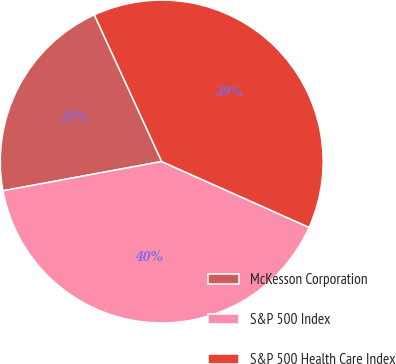Convert chart to OTSL. <chart><loc_0><loc_0><loc_500><loc_500><pie_chart><fcel>McKesson Corporation<fcel>S&P 500 Index<fcel>S&P 500 Health Care Index<nl><fcel>21.05%<fcel>40.41%<fcel>38.54%<nl></chart> 